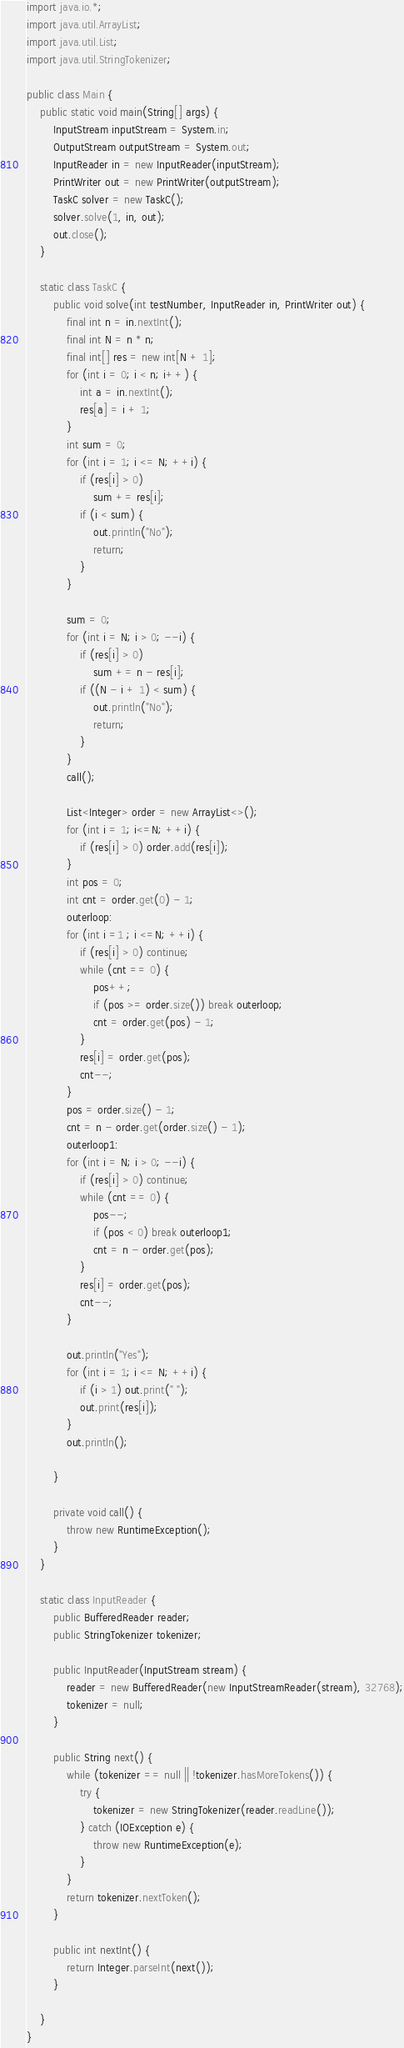Convert code to text. <code><loc_0><loc_0><loc_500><loc_500><_Java_>
import java.io.*;
import java.util.ArrayList;
import java.util.List;
import java.util.StringTokenizer;

public class Main {
    public static void main(String[] args) {
        InputStream inputStream = System.in;
        OutputStream outputStream = System.out;
        InputReader in = new InputReader(inputStream);
        PrintWriter out = new PrintWriter(outputStream);
        TaskC solver = new TaskC();
        solver.solve(1, in, out);
        out.close();
    }

    static class TaskC {
        public void solve(int testNumber, InputReader in, PrintWriter out) {
            final int n = in.nextInt();
            final int N = n * n;
            final int[] res = new int[N + 1];
            for (int i = 0; i < n; i++) {
                int a = in.nextInt();
                res[a] = i + 1;
            }
            int sum = 0;
            for (int i = 1; i <= N; ++i) {
                if (res[i] > 0)
                    sum += res[i];
                if (i < sum) {
                    out.println("No");
                    return;
                }
            }

            sum = 0;
            for (int i = N; i > 0; --i) {
                if (res[i] > 0)
                    sum += n - res[i];
                if ((N - i + 1) < sum) {
                    out.println("No");
                    return;
                }
            }
            call();

            List<Integer> order = new ArrayList<>();
            for (int i = 1; i<=N; ++i) {
                if (res[i] > 0) order.add(res[i]);
            }
            int pos = 0;
            int cnt = order.get(0) - 1;
            outerloop:
            for (int i =1 ; i <=N; ++i) {
                if (res[i] > 0) continue;
                while (cnt == 0) {
                    pos++;
                    if (pos >= order.size()) break outerloop;
                    cnt = order.get(pos) - 1;
                }
                res[i] = order.get(pos);
                cnt--;
            }
            pos = order.size() - 1;
            cnt = n - order.get(order.size() - 1);
            outerloop1:
            for (int i = N; i > 0; --i) {
                if (res[i] > 0) continue;
                while (cnt == 0) {
                    pos--;
                    if (pos < 0) break outerloop1;
                    cnt = n - order.get(pos);
                }
                res[i] = order.get(pos);
                cnt--;
            }

            out.println("Yes");
            for (int i = 1; i <= N; ++i) {
                if (i > 1) out.print(" ");
                out.print(res[i]);
            }
            out.println();

        }

        private void call() {
            throw new RuntimeException();
        }
    }

    static class InputReader {
        public BufferedReader reader;
        public StringTokenizer tokenizer;

        public InputReader(InputStream stream) {
            reader = new BufferedReader(new InputStreamReader(stream), 32768);
            tokenizer = null;
        }

        public String next() {
            while (tokenizer == null || !tokenizer.hasMoreTokens()) {
                try {
                    tokenizer = new StringTokenizer(reader.readLine());
                } catch (IOException e) {
                    throw new RuntimeException(e);
                }
            }
            return tokenizer.nextToken();
        }

        public int nextInt() {
            return Integer.parseInt(next());
        }

    }
}


</code> 